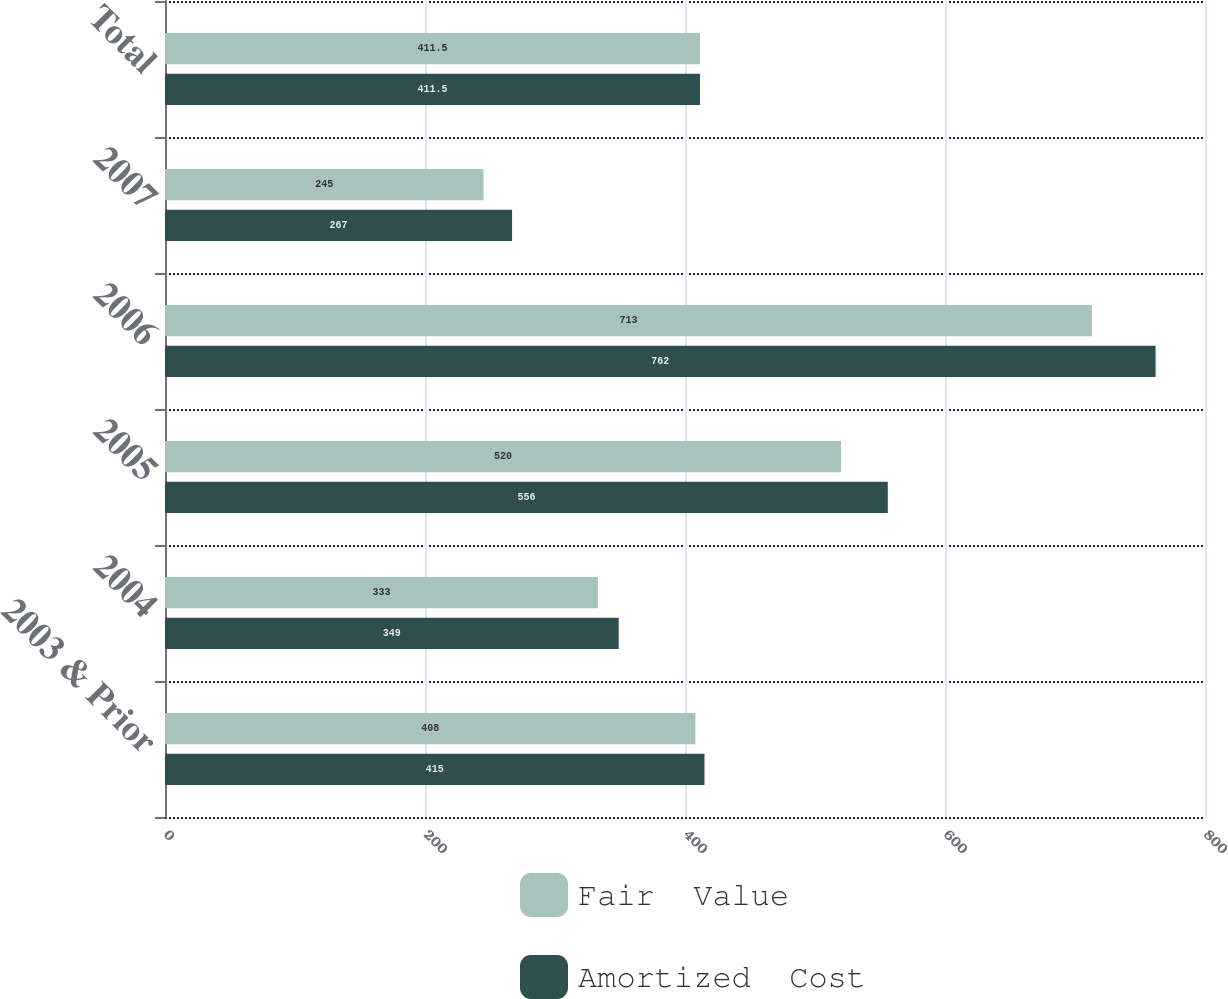Convert chart. <chart><loc_0><loc_0><loc_500><loc_500><stacked_bar_chart><ecel><fcel>2003 & Prior<fcel>2004<fcel>2005<fcel>2006<fcel>2007<fcel>Total<nl><fcel>Fair  Value<fcel>408<fcel>333<fcel>520<fcel>713<fcel>245<fcel>411.5<nl><fcel>Amortized  Cost<fcel>415<fcel>349<fcel>556<fcel>762<fcel>267<fcel>411.5<nl></chart> 